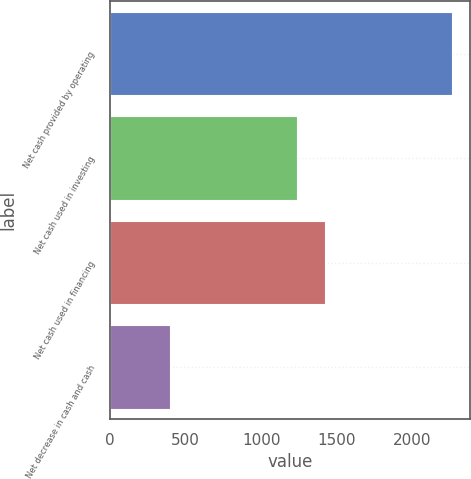<chart> <loc_0><loc_0><loc_500><loc_500><bar_chart><fcel>Net cash provided by operating<fcel>Net cash used in investing<fcel>Net cash used in financing<fcel>Net decrease in cash and cash<nl><fcel>2266<fcel>1234<fcel>1420.8<fcel>398<nl></chart> 